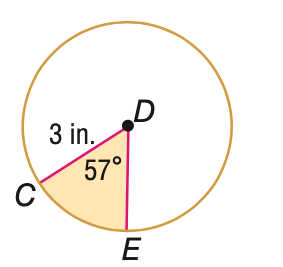Question: Find the area of the shaded sector. Round to the nearest tenth.
Choices:
A. 3.0
B. 4.5
C. 23.8
D. 28.3
Answer with the letter. Answer: B 